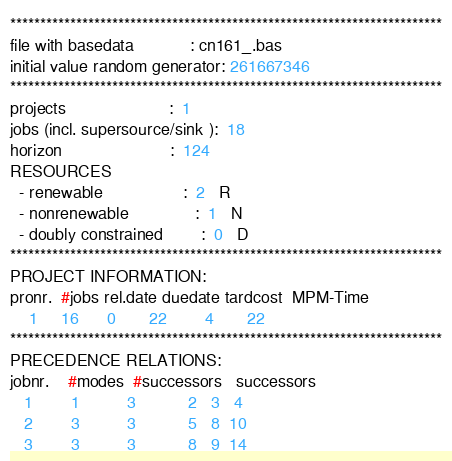<code> <loc_0><loc_0><loc_500><loc_500><_ObjectiveC_>************************************************************************
file with basedata            : cn161_.bas
initial value random generator: 261667346
************************************************************************
projects                      :  1
jobs (incl. supersource/sink ):  18
horizon                       :  124
RESOURCES
  - renewable                 :  2   R
  - nonrenewable              :  1   N
  - doubly constrained        :  0   D
************************************************************************
PROJECT INFORMATION:
pronr.  #jobs rel.date duedate tardcost  MPM-Time
    1     16      0       22        4       22
************************************************************************
PRECEDENCE RELATIONS:
jobnr.    #modes  #successors   successors
   1        1          3           2   3   4
   2        3          3           5   8  10
   3        3          3           8   9  14</code> 